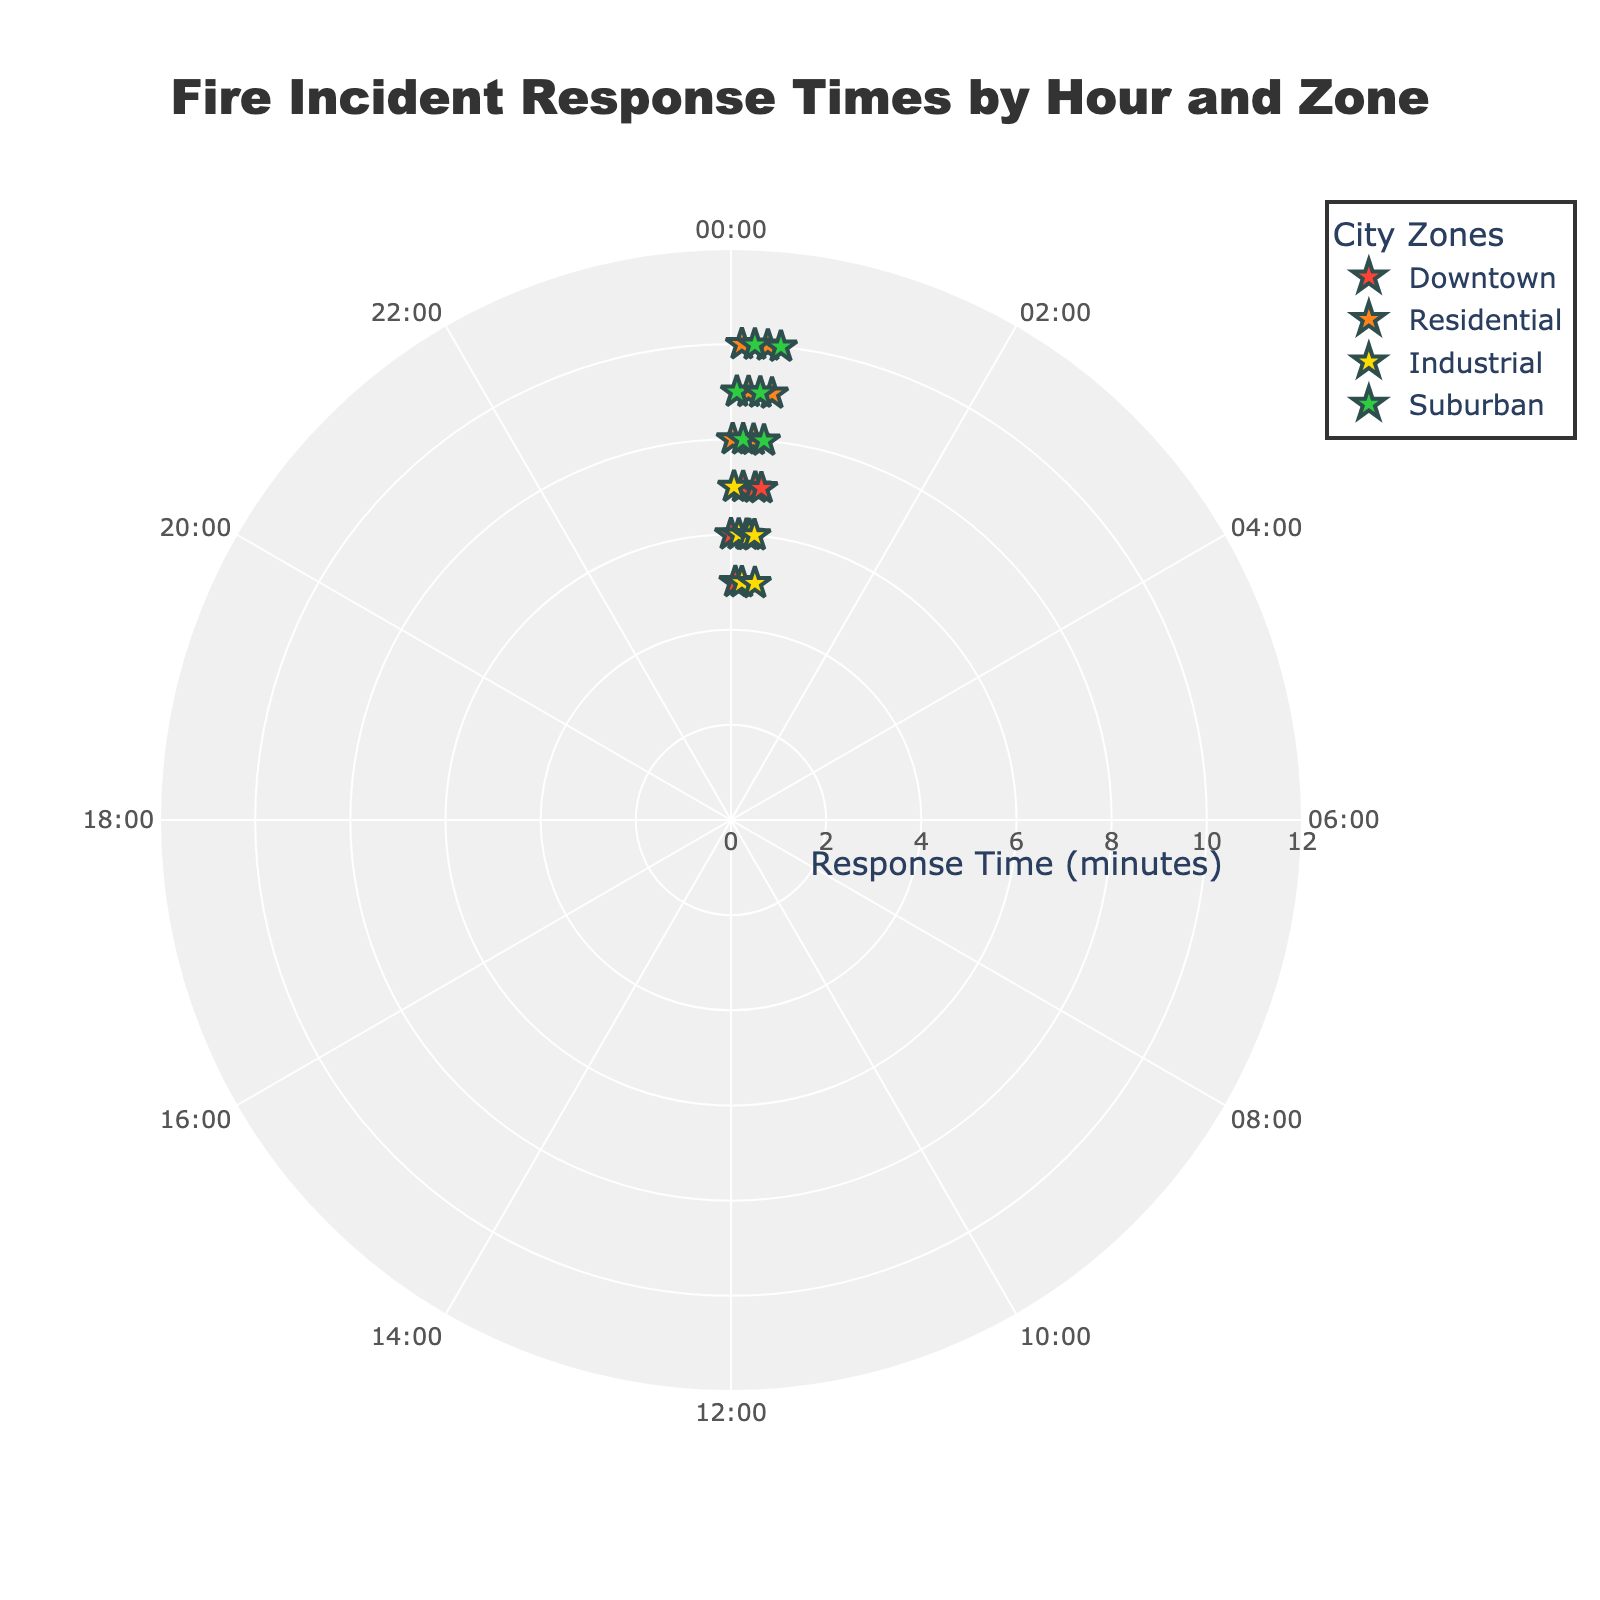What is the title of the figure? The title is usually displayed at the top center of the figure. In this case, it states "Fire Incident Response Times by Hour and Zone".
Answer: Fire Incident Response Times by Hour and Zone What is the range of response times displayed on the radial axis? The radial axis shows response times from 0 to 12 minutes, as indicated by the axis labels.
Answer: 0 to 12 minutes Which city zone has the most data points on the plot? By visual inspection, all zones (Downtown, Residential, Industrial, Suburban) seem to have an equal number of data points. Each zone shows a star marker for each hour of the day (24 data points total equally divided).
Answer: All zones equally At what hour does the Industrial zone have the shortest response time? Inspecting the data points for the Industrial zone, the shortest response time is at 10:00 and 22:00 hours, both showing 5 minutes.
Answer: 10:00 and 22:00 What is the response time for the Downtown zone at 4:00? Locate the Downtown markers, find the one at 4:00, the response time displayed is 5 minutes.
Answer: 5 minutes Compare the average response times for the Residential and Suburban zones. Which zone has a higher average? Calculate the average response times for both zones: Residential (8, 10, 9, 10, 8, 9) = (54/6) = 9 minutes; Suburban (9, 8, 10, 9, 8, 10) = (54/6) = 9 minutes. Both zones have the same average response time.
Answer: Both same Which city zone has the highest response time at any hour of the day? The highest response time across all zones and hours is 10 minutes. This value is observed in both the Residential and Suburban zones.
Answer: Residential and Suburban Describe the symbol and color used for the Industrial zone. The Industrial zone is marked with star-shaped symbols. The color associated with it is the third color in the custom scale, which is yellow (#FFDC00).
Answer: Star and yellow Does the response time in the Downtown zone show any noticeable pattern over the hours? By looking at the markers for the Downtown zone, there isn't a clear upward or downward trend, but it tends to range between 5 and 7 minutes consistently.
Answer: No clear pattern If we wanted to find the median response time for the Suburban zone, what would it be? Collect the data for the Suburban zone (9, 8, 10, 9, 8, 10). Sort these values (8, 8, 9, 9, 10, 10). The median is the average of the middle two numbers (9 and 9), which is 9 minutes.
Answer: 9 minutes 